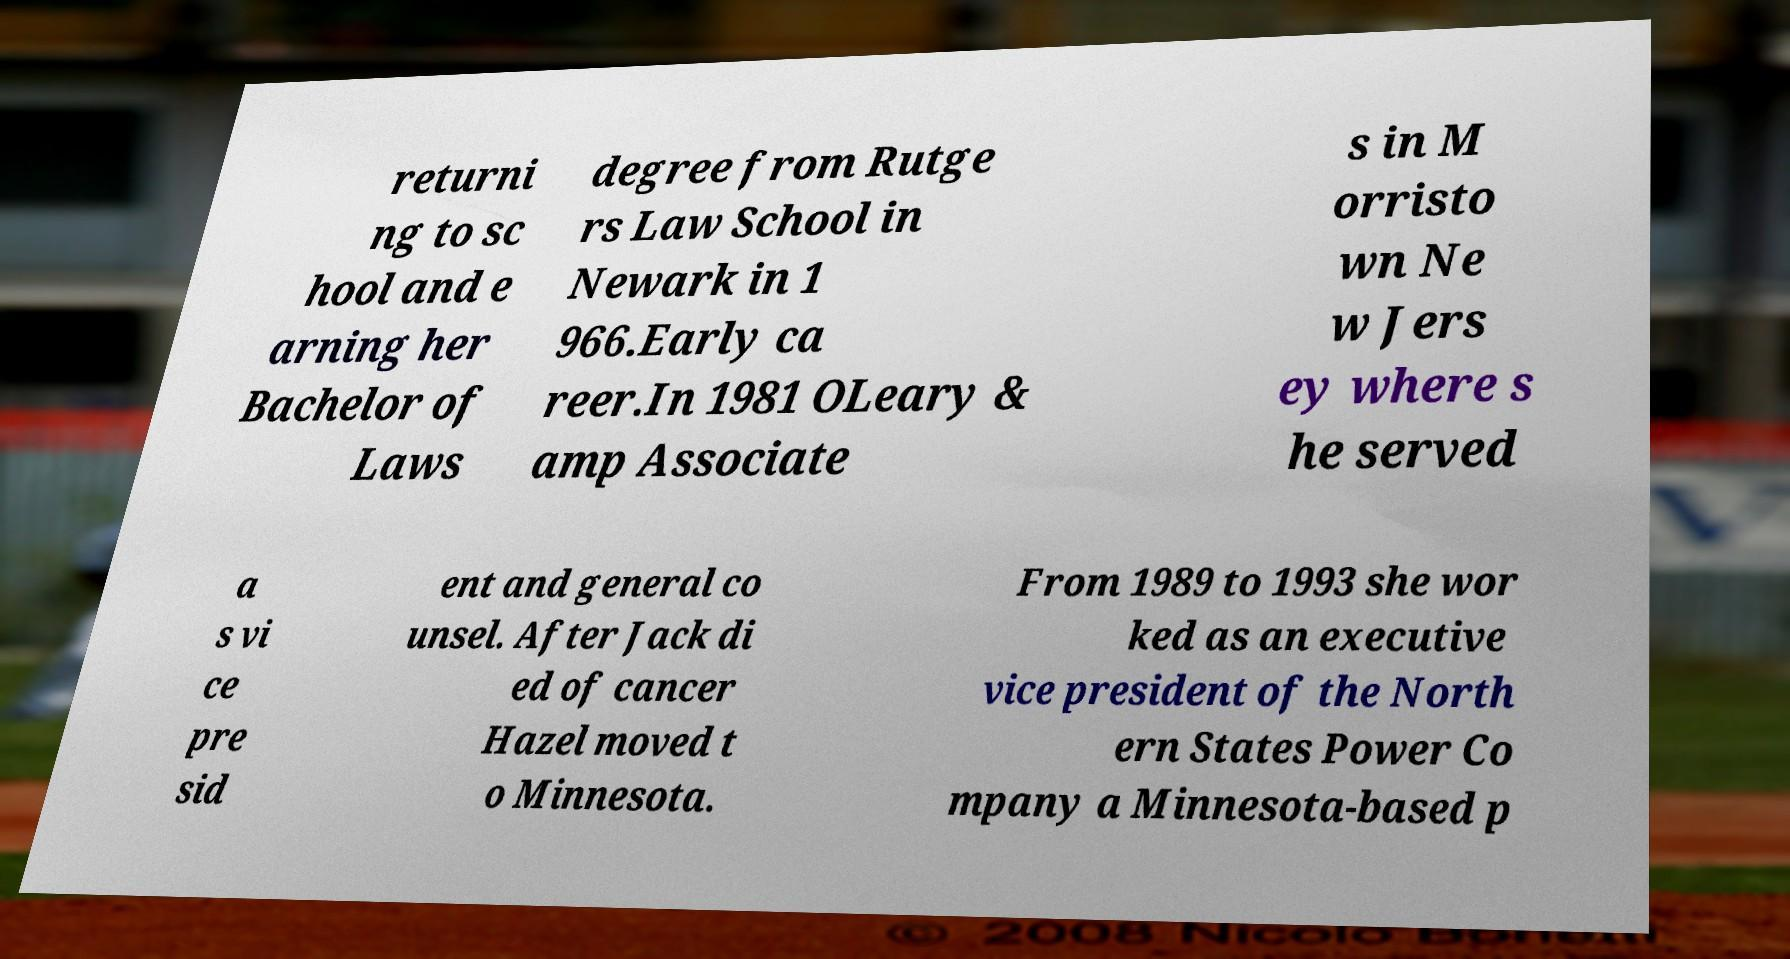Please read and relay the text visible in this image. What does it say? returni ng to sc hool and e arning her Bachelor of Laws degree from Rutge rs Law School in Newark in 1 966.Early ca reer.In 1981 OLeary & amp Associate s in M orristo wn Ne w Jers ey where s he served a s vi ce pre sid ent and general co unsel. After Jack di ed of cancer Hazel moved t o Minnesota. From 1989 to 1993 she wor ked as an executive vice president of the North ern States Power Co mpany a Minnesota-based p 